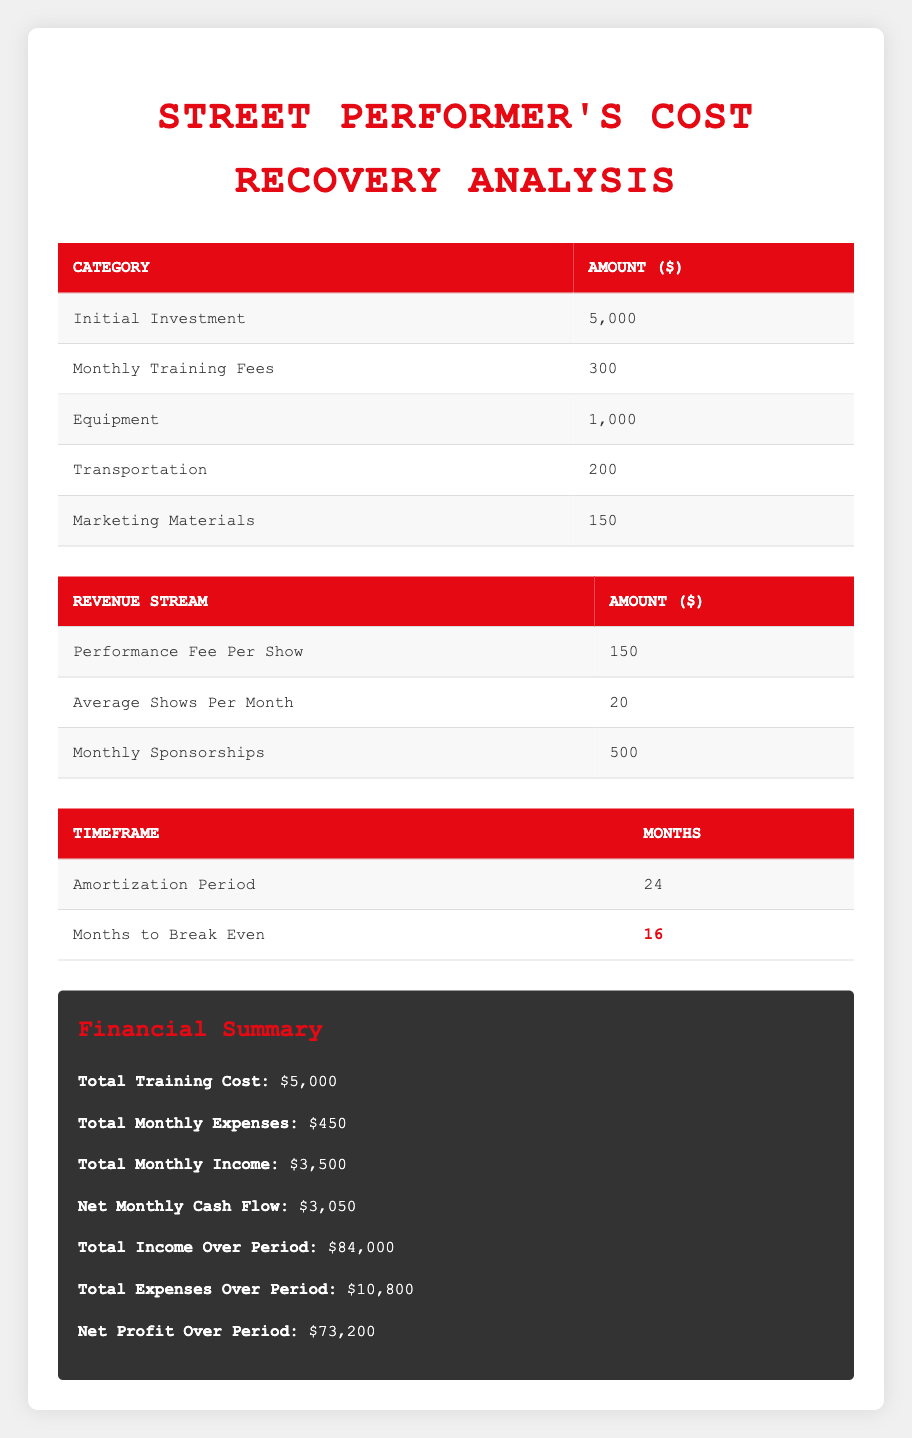What is the total initial investment for the street performer? The table shows the "Initial Investment" category with a corresponding amount of 5,000.
Answer: 5,000 How much is spent on monthly training fees? The table lists "Monthly Training Fees" as 300.
Answer: 300 What is the total cost of additional expenses for equipment, transportation, and marketing materials? By adding up the costs displayed in the additional expenses section: 1,000 (equipment) + 200 (transportation) + 150 (marketing materials) = 1,350.
Answer: 1,350 Does the street performer earn more from performance fees or monthly sponsorships? The performance fee per show is 150 and with an average of 20 shows per month, the total performance income is 150 * 20 = 3,000. The monthly sponsorships amount to 500. Since 3,000 > 500, the performer earns more from performance fees.
Answer: Yes What is the net monthly cash flow for the street performer? The table states the "Net Monthly Cash Flow" is 3,050.
Answer: 3,050 How long is the amortization period? The table indicates that the amortization period is 24 months.
Answer: 24 What is the total income expected over the 24-month period? According to the table, the "Total Income Over Period" is provided as 84,000.
Answer: 84,000 How many months does it take for the street performer to break even? The table shows "Months to Break Even" is highlighted as 16.
Answer: 16 What is the difference between total income over the period and total expenses over the period? The total income is 84,000 and the total expenses are 10,800. The difference is calculated as 84,000 - 10,800 = 73,200.
Answer: 73,200 What are the total monthly expenses for the street performer? The total monthly expenses are clearly stated in the table as 450.
Answer: 450 